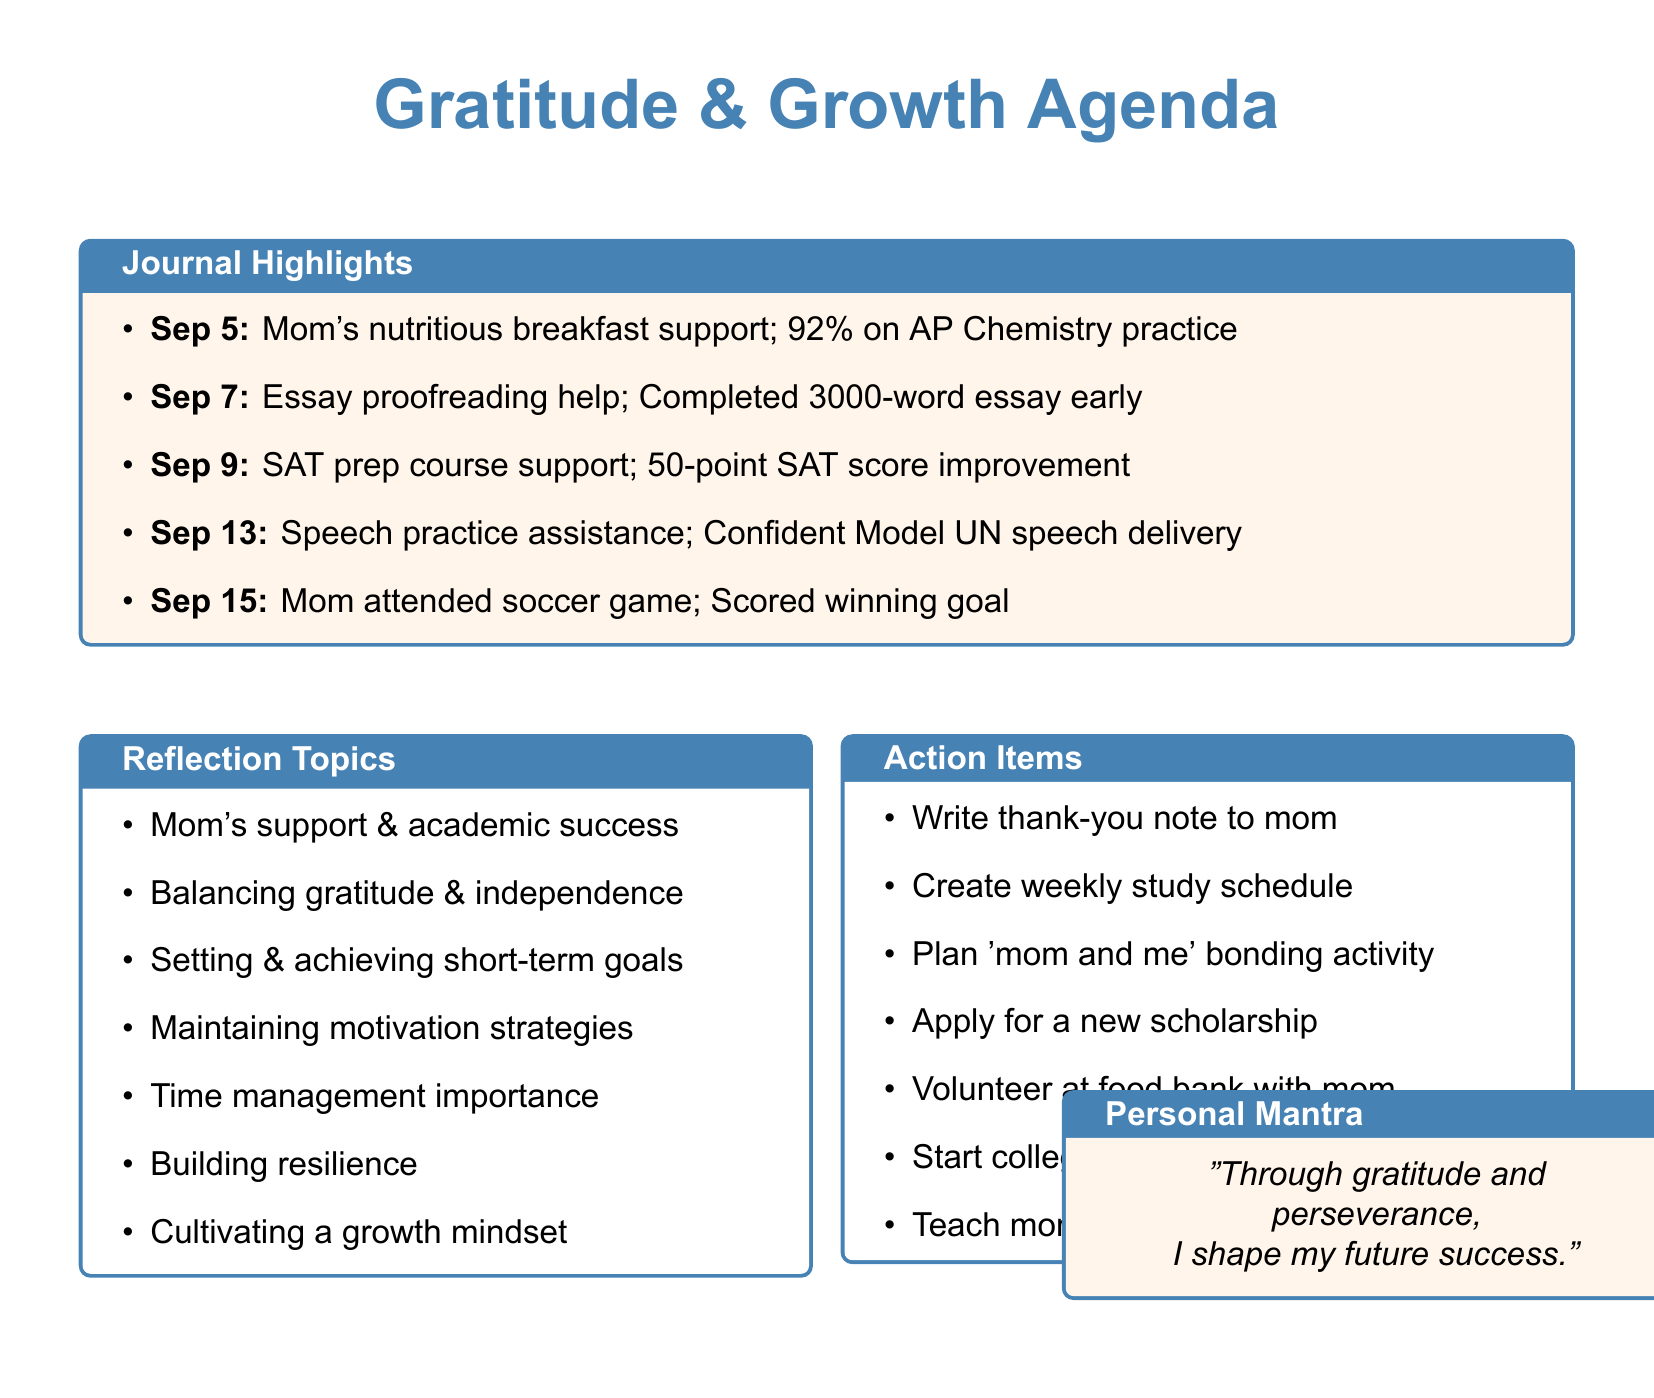What date did mom prepare breakfast for AP Chemistry? The specific date is mentioned as the day the breakfast was prepared, which is September 5.
Answer: September 5 What was the personal achievement on September 7? This achievement is found in the journal entry for September 7, stating that the essay was completed early.
Answer: Completed 3000-word essay early How many points did the SAT practice score improve by? The improvement is stated as a numerical value in the entry from September 9.
Answer: 50 points What did mom prepare for dinner on September 11? This information is found in the entry for September 11, highlighting what mom made in celebration of an achievement.
Answer: Lasagna Which event did mom attend on September 15? The event is specified in the September 15 journal entry where her attendance is noted.
Answer: Soccer game What overarching theme is addressed in the reflection topics? The topics focus on the role of support in success, which can be inferred from the content provided.
Answer: Mom's support & academic success What is one action item listed in the agenda? The document details various action items, one of which involves a thank-you note.
Answer: Write thank-you note to mom What does the personal mantra emphasize? The mantra found at the end of the document reflects the relationship between gratitude and success.
Answer: Gratitude and perseverance What is the total number of journal entries included? The total entries are quantifiable based on the list presented in the document.
Answer: 7 entries 